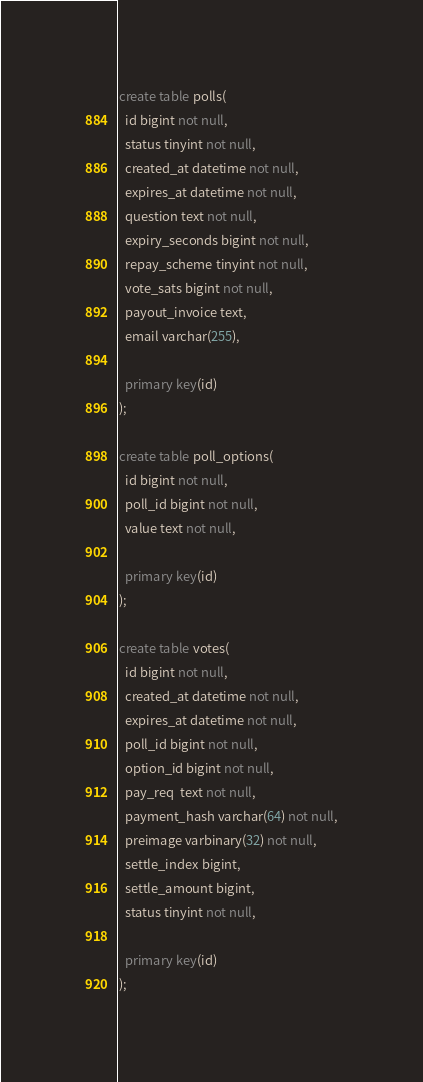<code> <loc_0><loc_0><loc_500><loc_500><_SQL_>create table polls(
  id bigint not null,
  status tinyint not null,
  created_at datetime not null,
  expires_at datetime not null,
  question text not null,
  expiry_seconds bigint not null,
  repay_scheme tinyint not null,
  vote_sats bigint not null,
  payout_invoice text,
  email varchar(255),

  primary key(id)
);

create table poll_options(
  id bigint not null,
  poll_id bigint not null,
  value text not null,

  primary key(id)
);

create table votes(
  id bigint not null,
  created_at datetime not null,
  expires_at datetime not null,
  poll_id bigint not null,
  option_id bigint not null,
  pay_req  text not null,
  payment_hash varchar(64) not null,
  preimage varbinary(32) not null,
  settle_index bigint,
  settle_amount bigint,
  status tinyint not null,

  primary key(id)
);
</code> 